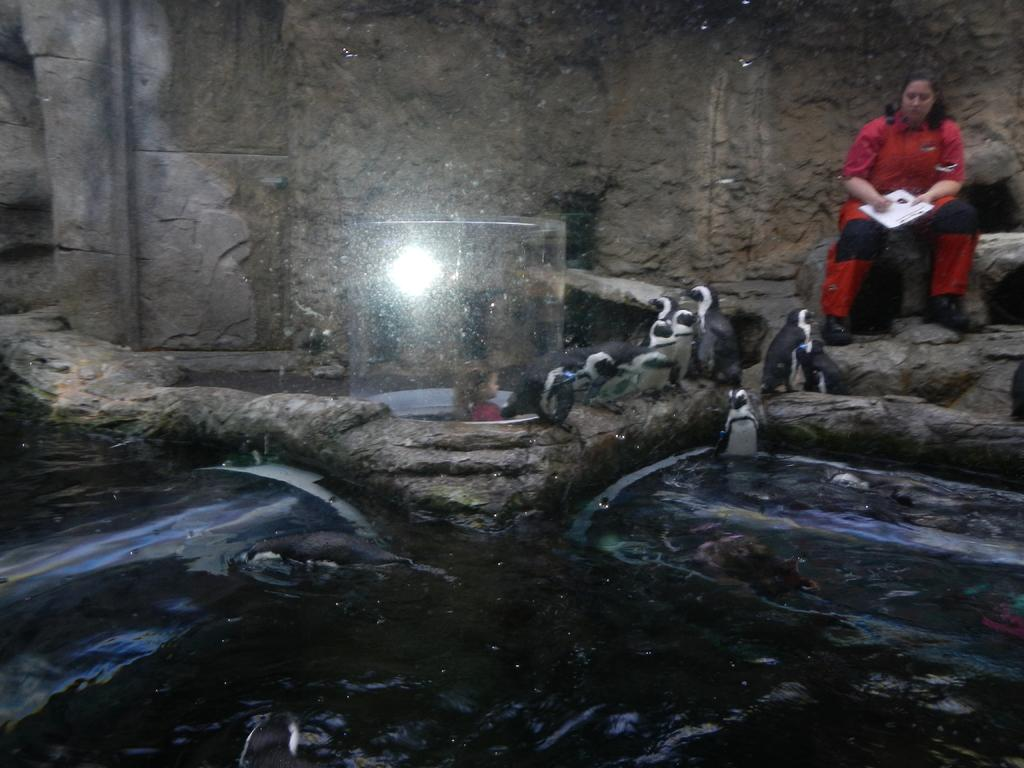What animals are located in the middle of the image? There are birds in the middle of the image. Who is sitting behind the birds? A woman is sitting behind the birds. What is the woman holding? The woman is holding a book. What can be seen at the top of the image? There is a wall visible at the top of the image. What type of car is parked next to the woman in the image? There is no car present in the image; it features birds and a woman sitting behind them. What emotion is the woman expressing towards the birds in the image? The image does not show the woman's emotions or expressions towards the birds, so it cannot be determined from the picture. 